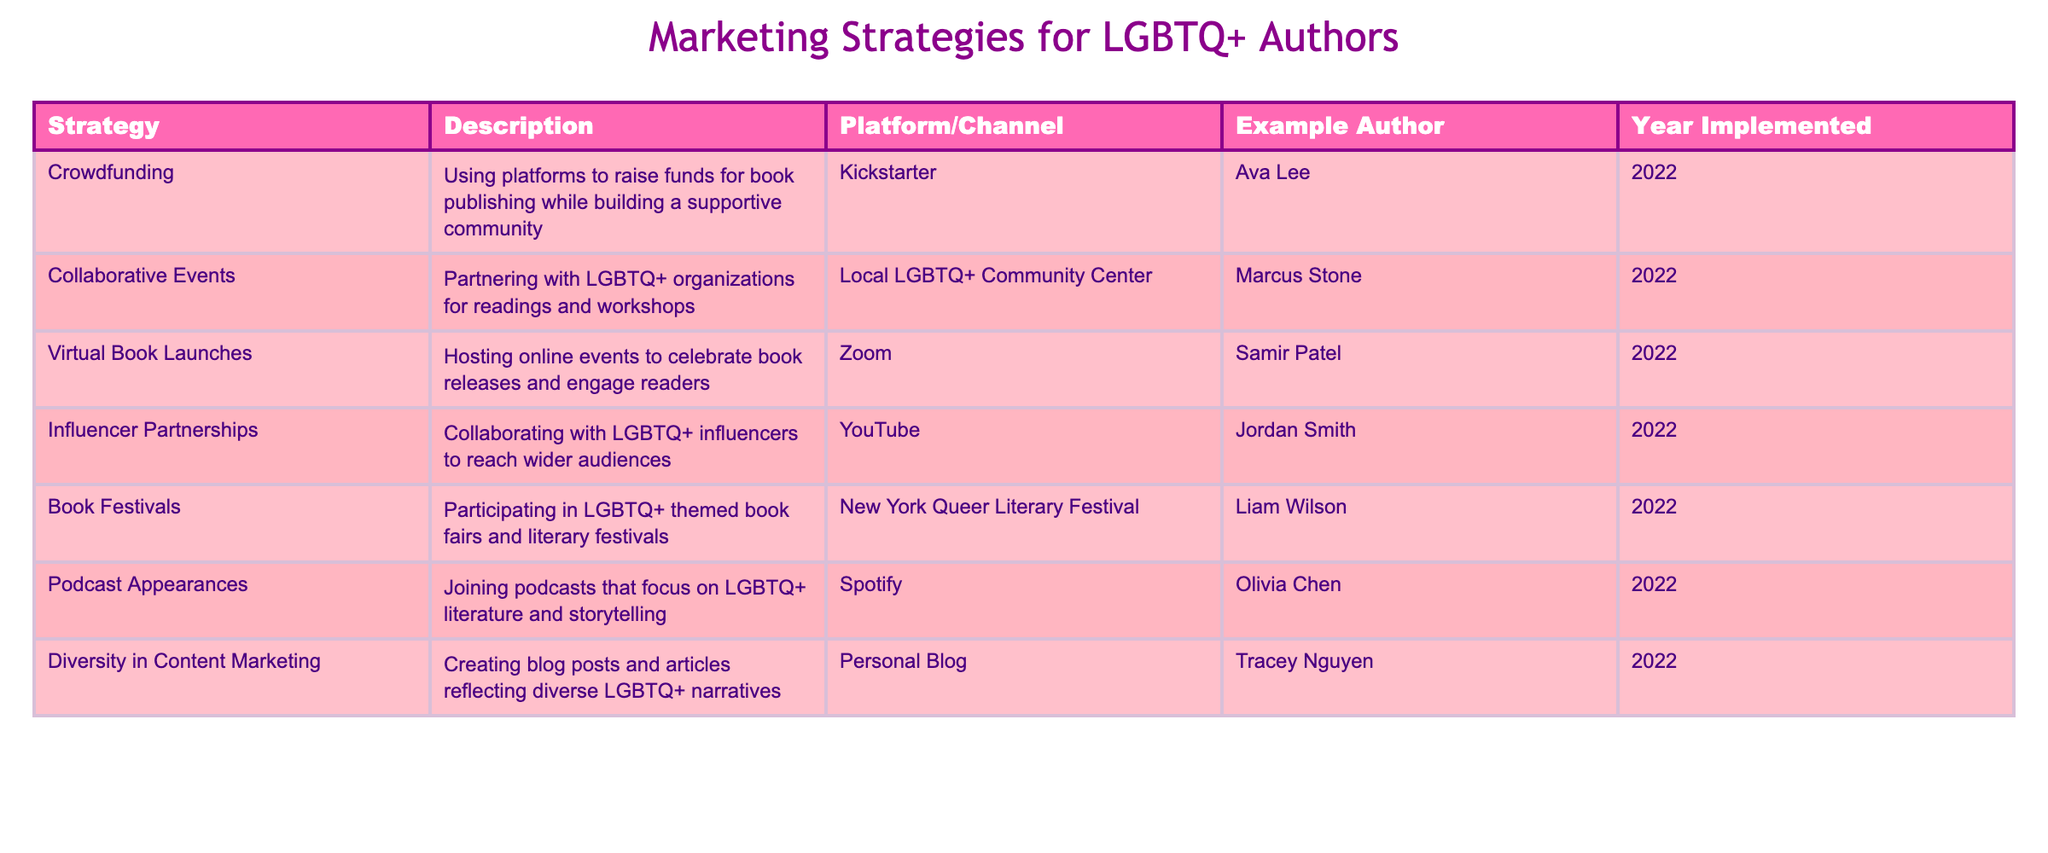What marketing strategy did Ava Lee use in 2022? The table shows that Ava Lee implemented the crowdfunding strategy to raise funds for book publishing while building a supportive community in 2022.
Answer: Crowdfunding Which platform was used for Samir Patel's virtual book launch? According to the table, Samir Patel used Zoom as the platform for his virtual book launch event in 2022.
Answer: Zoom How many authors participated in book festivals in 2022? The table indicates that only one author, Liam Wilson, participated in book festivals in 2022.
Answer: 1 Is collaboration with LGBTQ+ organizations part of the marketing strategies listed? Yes, the table includes collaborative events as a strategy where Marcus Stone partnered with a local LGBTQ+ community center for readings and workshops in 2022.
Answer: Yes What is the difference in the number of platforms between crowdfunding and influencer partnerships? Crowdfunding uses one platform (Kickstarter), while influencer partnerships use one platform (YouTube). Therefore, the difference in the number of platforms is 1 - 1 = 0.
Answer: 0 Which strategy had the most varied platforms based on the table? The table suggests that all strategies are limited to specific platforms; however, both crowdfunding and influencer partnerships only mentioned one platform each. Thus, no strategy shows more varied platforms than others.
Answer: None How many authors used personal blogs for diversity in content marketing? The table shows that only one author, Tracey Nguyen, used personal blogs as a channel for diversity in content marketing.
Answer: 1 Did Marcus Stone implement a strategy that involved local LGBTQ+ venues? Yes, Marcus Stone implemented collaborative events, partnering with a local LGBTQ+ community center in 2022, which involves local LGBTQ+ venues.
Answer: Yes What are the two main types of marketing strategies listed for LGBTQ+ authors in 2022? The table categorizes strategies into event-based (like collaborative events and virtual book launches) and content-based (like diversity in content marketing and podcast appearances). Therefore, the two main types are event-based and content-based.
Answer: Event-based and content-based 